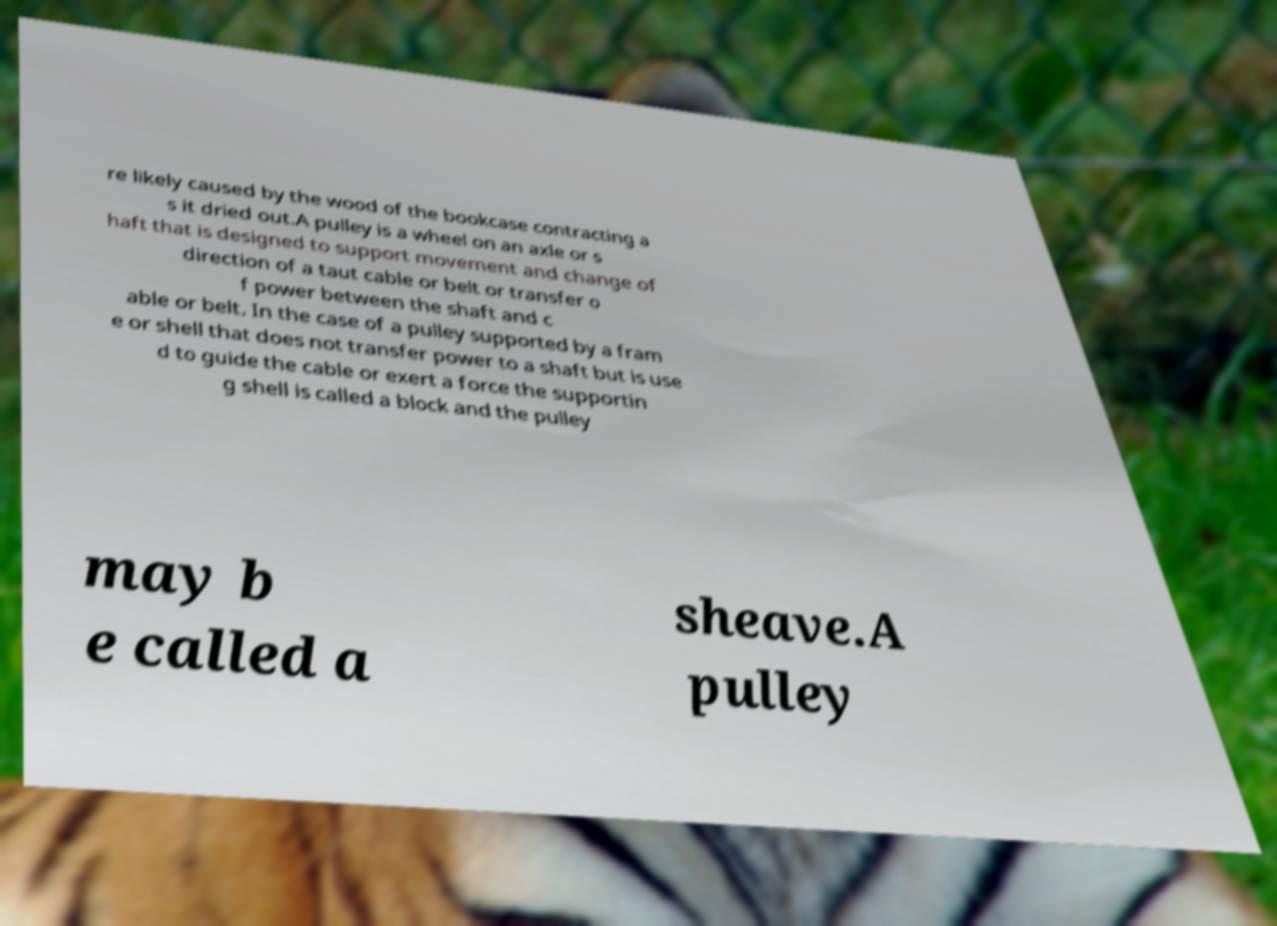For documentation purposes, I need the text within this image transcribed. Could you provide that? re likely caused by the wood of the bookcase contracting a s it dried out.A pulley is a wheel on an axle or s haft that is designed to support movement and change of direction of a taut cable or belt or transfer o f power between the shaft and c able or belt. In the case of a pulley supported by a fram e or shell that does not transfer power to a shaft but is use d to guide the cable or exert a force the supportin g shell is called a block and the pulley may b e called a sheave.A pulley 